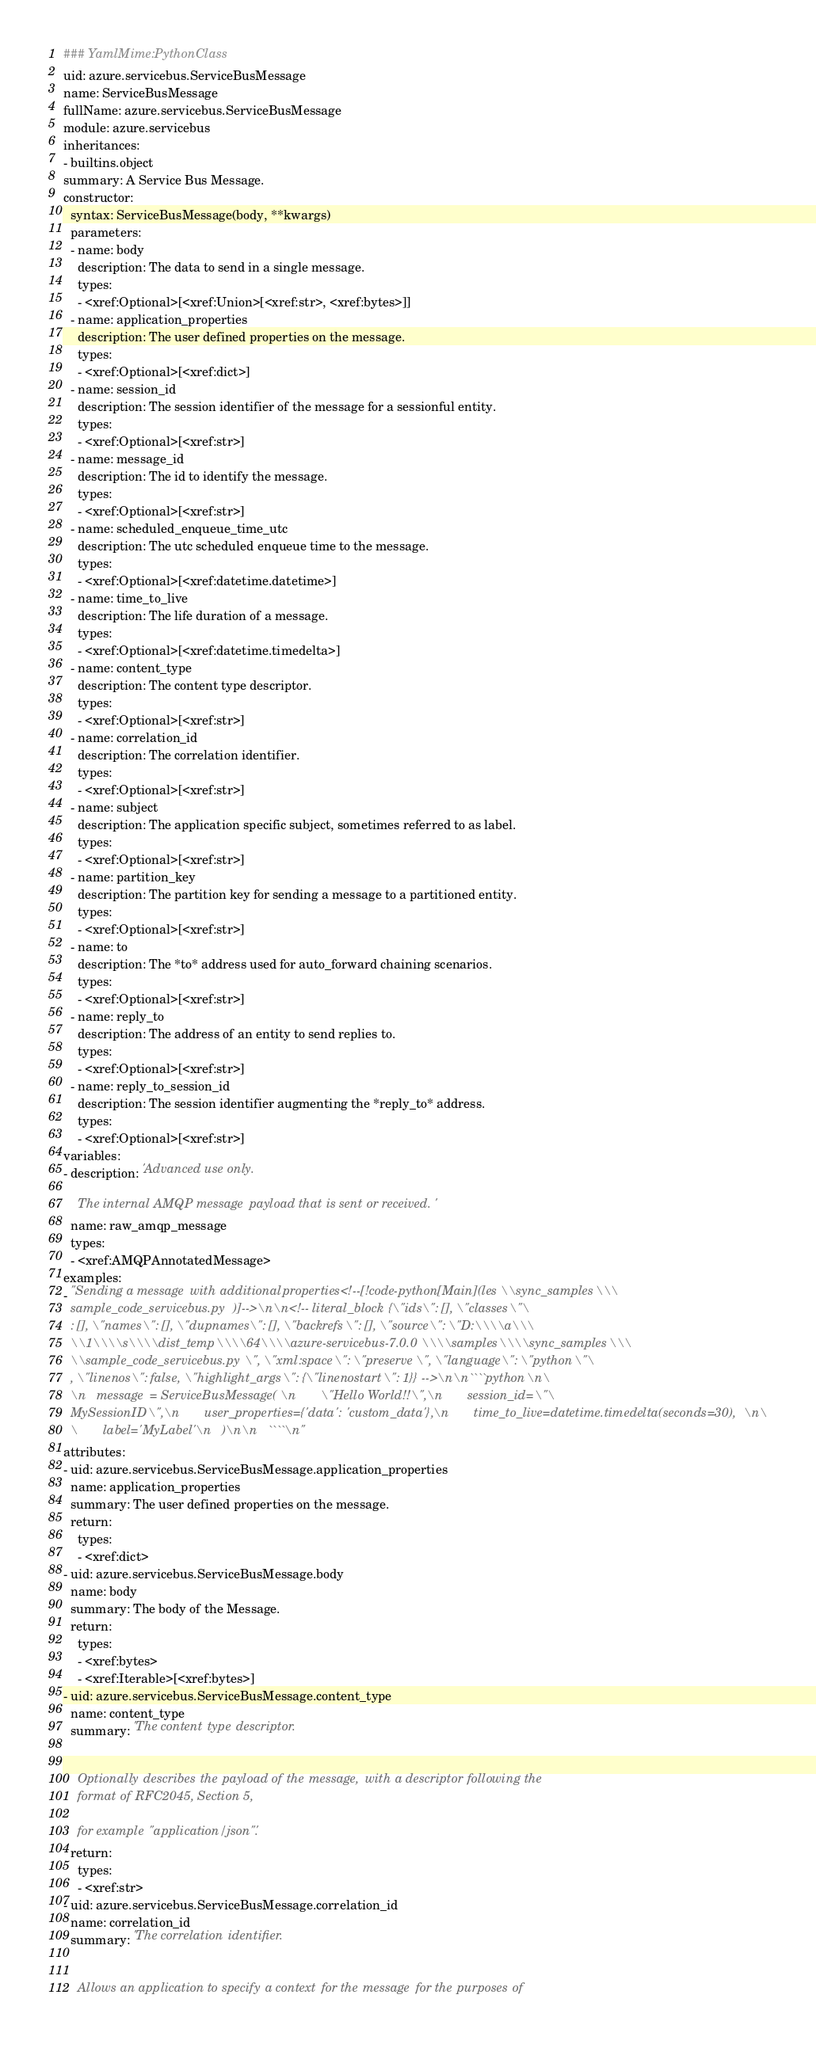Convert code to text. <code><loc_0><loc_0><loc_500><loc_500><_YAML_>### YamlMime:PythonClass
uid: azure.servicebus.ServiceBusMessage
name: ServiceBusMessage
fullName: azure.servicebus.ServiceBusMessage
module: azure.servicebus
inheritances:
- builtins.object
summary: A Service Bus Message.
constructor:
  syntax: ServiceBusMessage(body, **kwargs)
  parameters:
  - name: body
    description: The data to send in a single message.
    types:
    - <xref:Optional>[<xref:Union>[<xref:str>, <xref:bytes>]]
  - name: application_properties
    description: The user defined properties on the message.
    types:
    - <xref:Optional>[<xref:dict>]
  - name: session_id
    description: The session identifier of the message for a sessionful entity.
    types:
    - <xref:Optional>[<xref:str>]
  - name: message_id
    description: The id to identify the message.
    types:
    - <xref:Optional>[<xref:str>]
  - name: scheduled_enqueue_time_utc
    description: The utc scheduled enqueue time to the message.
    types:
    - <xref:Optional>[<xref:datetime.datetime>]
  - name: time_to_live
    description: The life duration of a message.
    types:
    - <xref:Optional>[<xref:datetime.timedelta>]
  - name: content_type
    description: The content type descriptor.
    types:
    - <xref:Optional>[<xref:str>]
  - name: correlation_id
    description: The correlation identifier.
    types:
    - <xref:Optional>[<xref:str>]
  - name: subject
    description: The application specific subject, sometimes referred to as label.
    types:
    - <xref:Optional>[<xref:str>]
  - name: partition_key
    description: The partition key for sending a message to a partitioned entity.
    types:
    - <xref:Optional>[<xref:str>]
  - name: to
    description: The *to* address used for auto_forward chaining scenarios.
    types:
    - <xref:Optional>[<xref:str>]
  - name: reply_to
    description: The address of an entity to send replies to.
    types:
    - <xref:Optional>[<xref:str>]
  - name: reply_to_session_id
    description: The session identifier augmenting the *reply_to* address.
    types:
    - <xref:Optional>[<xref:str>]
variables:
- description: 'Advanced use only.

    The internal AMQP message payload that is sent or received.'
  name: raw_amqp_message
  types:
  - <xref:AMQPAnnotatedMessage>
examples:
- "Sending a message with additional properties<!--[!code-python[Main](les\\sync_samples\\\
  sample_code_servicebus.py )]-->\n\n<!-- literal_block {\"ids\": [], \"classes\"\
  : [], \"names\": [], \"dupnames\": [], \"backrefs\": [], \"source\": \"D:\\\\a\\\
  \\1\\\\s\\\\dist_temp\\\\64\\\\azure-servicebus-7.0.0\\\\samples\\\\sync_samples\\\
  \\sample_code_servicebus.py\", \"xml:space\": \"preserve\", \"language\": \"python\"\
  , \"linenos\": false, \"highlight_args\": {\"linenostart\": 1}} -->\n\n````python\n\
  \n   message = ServiceBusMessage(\n       \"Hello World!!\",\n       session_id=\"\
  MySessionID\",\n       user_properties={'data': 'custom_data'},\n       time_to_live=datetime.timedelta(seconds=30),\n\
  \       label='MyLabel'\n   )\n\n   ````\n"
attributes:
- uid: azure.servicebus.ServiceBusMessage.application_properties
  name: application_properties
  summary: The user defined properties on the message.
  return:
    types:
    - <xref:dict>
- uid: azure.servicebus.ServiceBusMessage.body
  name: body
  summary: The body of the Message.
  return:
    types:
    - <xref:bytes>
    - <xref:Iterable>[<xref:bytes>]
- uid: azure.servicebus.ServiceBusMessage.content_type
  name: content_type
  summary: 'The content type descriptor.


    Optionally describes the payload of the message, with a descriptor following the
    format of RFC2045, Section 5,

    for example "application/json".'
  return:
    types:
    - <xref:str>
- uid: azure.servicebus.ServiceBusMessage.correlation_id
  name: correlation_id
  summary: 'The correlation identifier.


    Allows an application to specify a context for the message for the purposes of</code> 